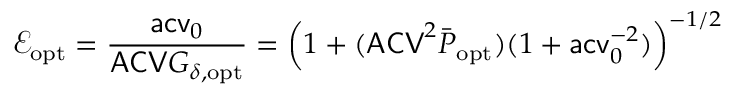Convert formula to latex. <formula><loc_0><loc_0><loc_500><loc_500>\mathcal { E } _ { o p t } = \frac { a c v _ { 0 } } { A C V G _ { \delta , o p t } } = \left ( 1 + ( A C V ^ { 2 } \bar { P } _ { o p t } ) ( 1 + a c v _ { 0 } ^ { - 2 } ) \right ) ^ { - 1 / 2 }</formula> 